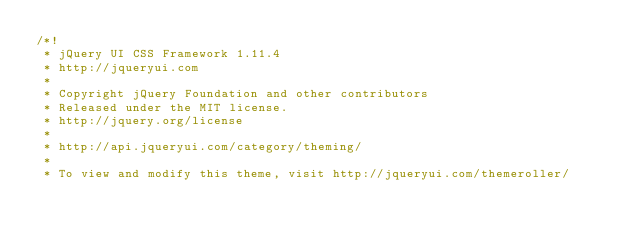<code> <loc_0><loc_0><loc_500><loc_500><_CSS_>/*!
 * jQuery UI CSS Framework 1.11.4
 * http://jqueryui.com
 *
 * Copyright jQuery Foundation and other contributors
 * Released under the MIT license.
 * http://jquery.org/license
 *
 * http://api.jqueryui.com/category/theming/
 *
 * To view and modify this theme, visit http://jqueryui.com/themeroller/</code> 